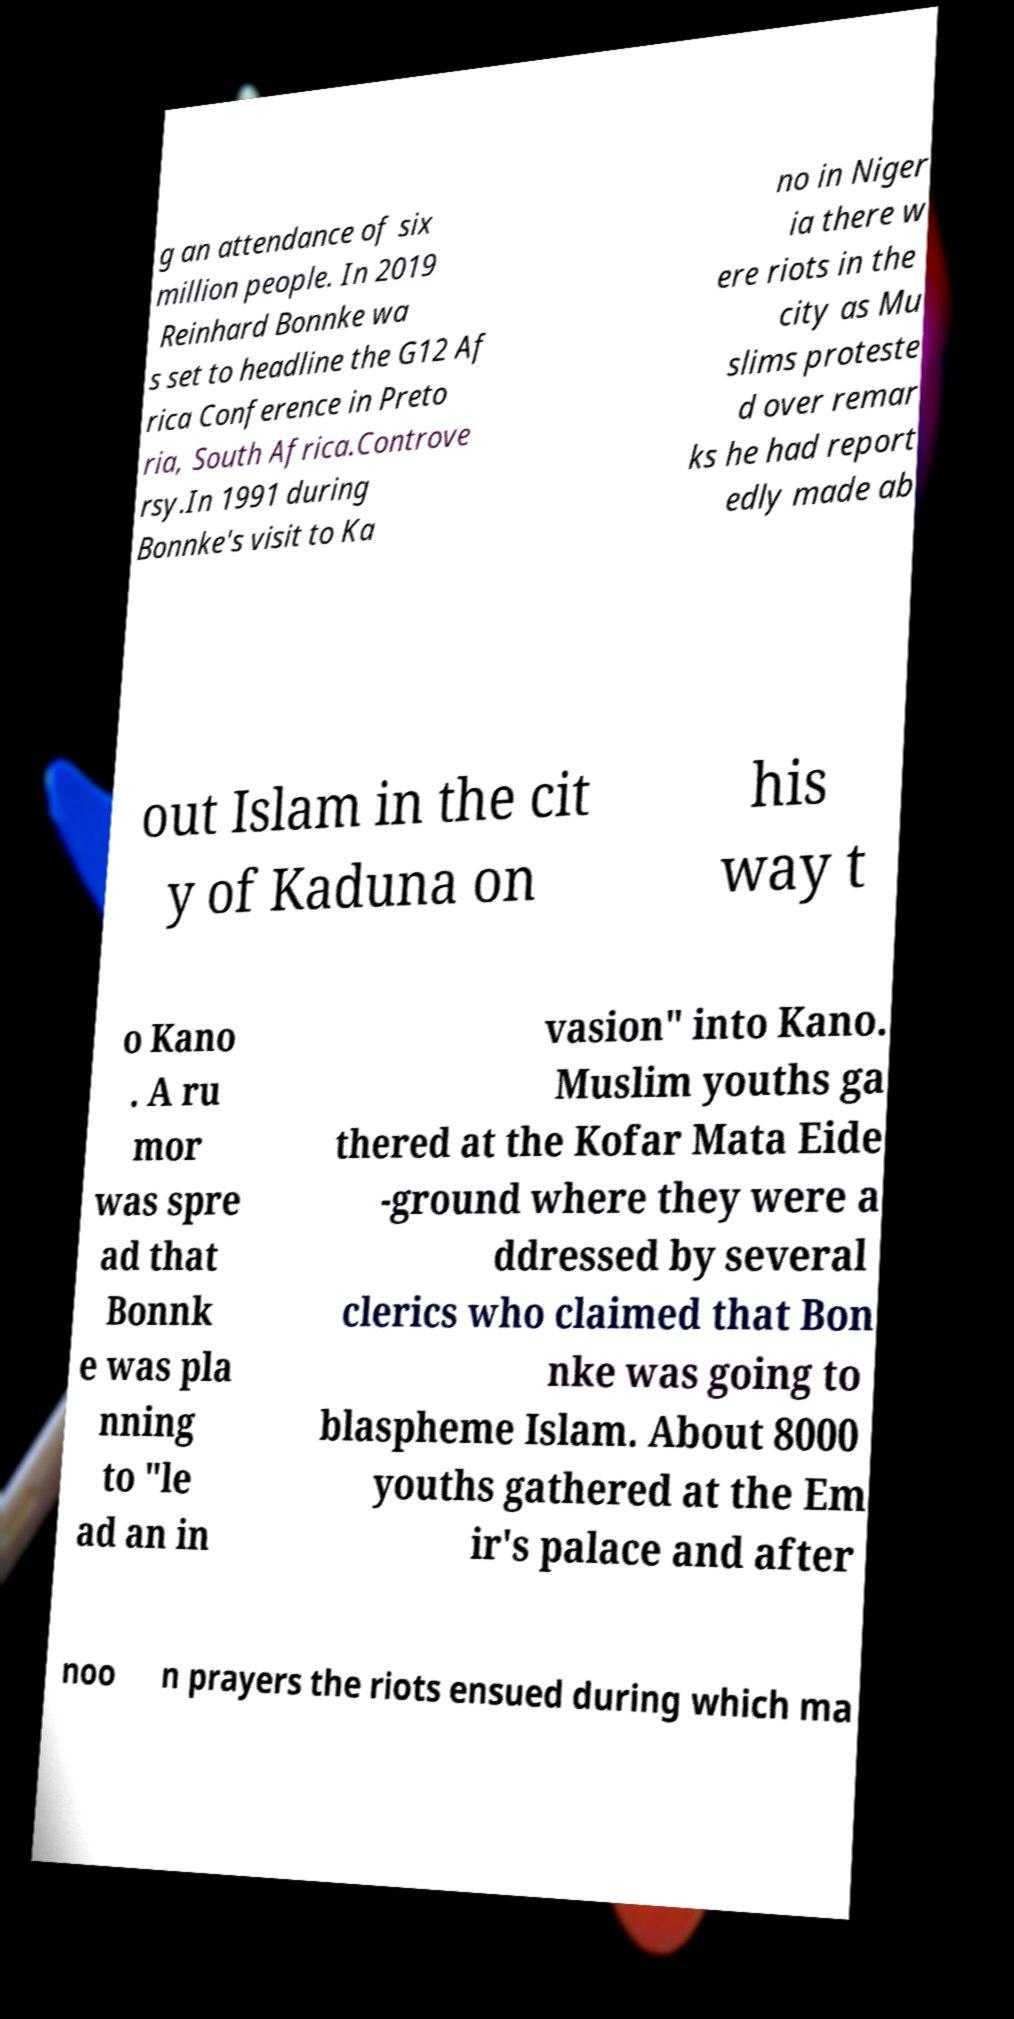I need the written content from this picture converted into text. Can you do that? g an attendance of six million people. In 2019 Reinhard Bonnke wa s set to headline the G12 Af rica Conference in Preto ria, South Africa.Controve rsy.In 1991 during Bonnke's visit to Ka no in Niger ia there w ere riots in the city as Mu slims proteste d over remar ks he had report edly made ab out Islam in the cit y of Kaduna on his way t o Kano . A ru mor was spre ad that Bonnk e was pla nning to "le ad an in vasion" into Kano. Muslim youths ga thered at the Kofar Mata Eide -ground where they were a ddressed by several clerics who claimed that Bon nke was going to blaspheme Islam. About 8000 youths gathered at the Em ir's palace and after noo n prayers the riots ensued during which ma 